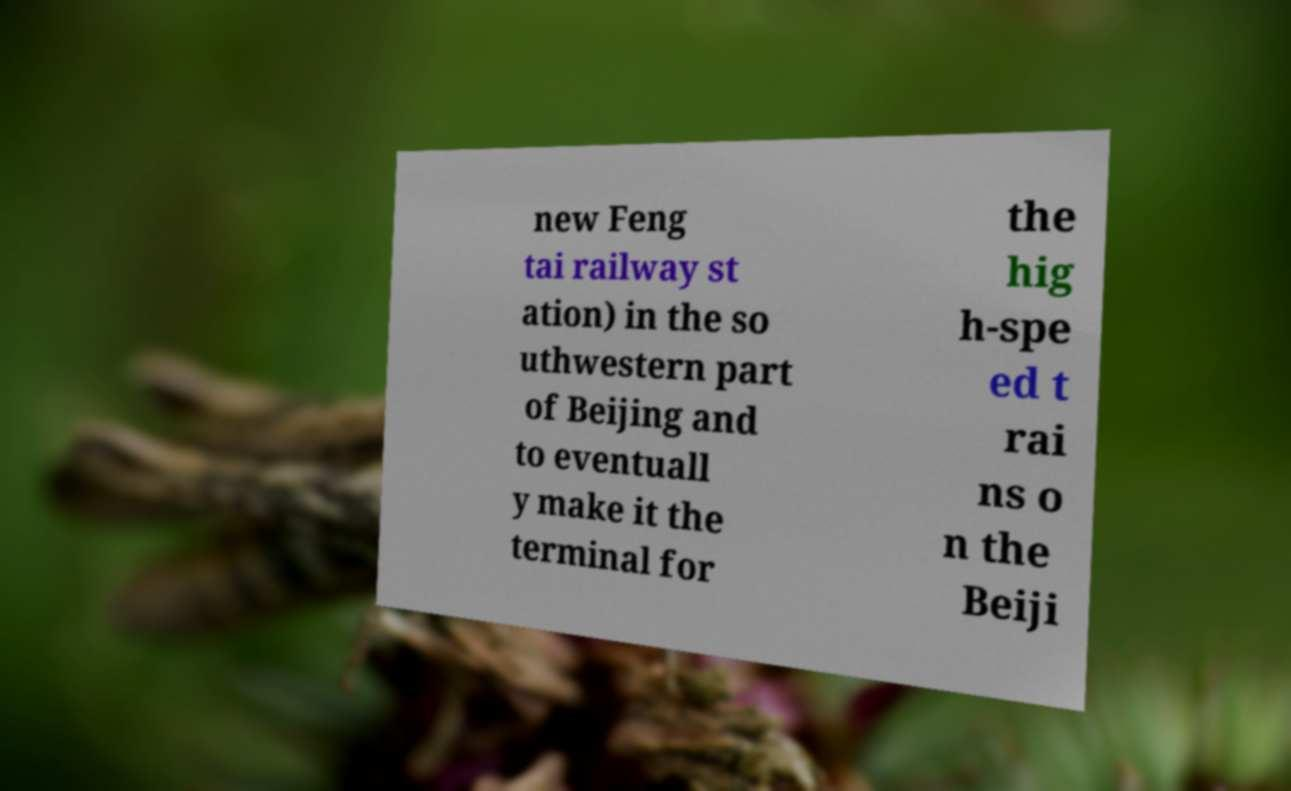I need the written content from this picture converted into text. Can you do that? new Feng tai railway st ation) in the so uthwestern part of Beijing and to eventuall y make it the terminal for the hig h-spe ed t rai ns o n the Beiji 